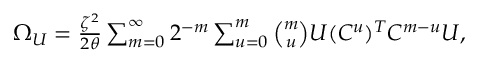<formula> <loc_0><loc_0><loc_500><loc_500>\begin{array} { r } { \Omega _ { U } = \frac { \zeta ^ { 2 } } { 2 \theta } \sum _ { m = 0 } ^ { \infty } { 2 ^ { - m } \sum _ { u = 0 } ^ { m } { \binom { m } { u } U ( C ^ { u } ) ^ { T } C ^ { m - u } U } } , } \end{array}</formula> 